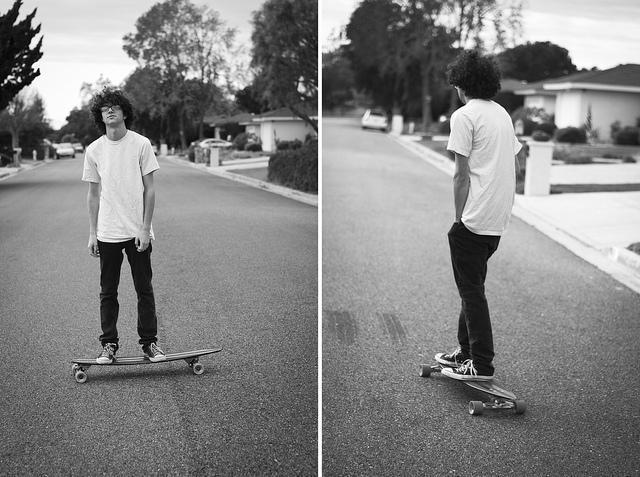How many people are there?
Give a very brief answer. 2. 